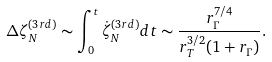Convert formula to latex. <formula><loc_0><loc_0><loc_500><loc_500>\Delta \zeta _ { N } ^ { ( 3 r d ) } \sim \int _ { 0 } ^ { t } \dot { \zeta } _ { N } ^ { ( 3 r d ) } d t \sim \frac { r _ { \Gamma } ^ { 7 / 4 } } { r _ { T } ^ { 3 / 2 } ( 1 + r _ { \Gamma } ) } .</formula> 